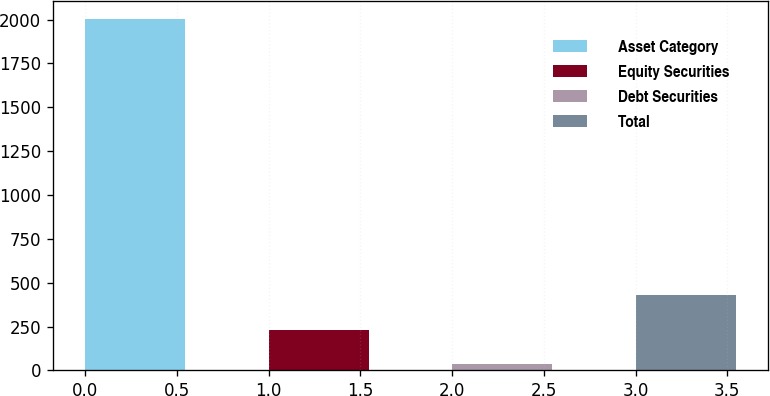<chart> <loc_0><loc_0><loc_500><loc_500><bar_chart><fcel>Asset Category<fcel>Equity Securities<fcel>Debt Securities<fcel>Total<nl><fcel>2003<fcel>231.8<fcel>35<fcel>428.6<nl></chart> 